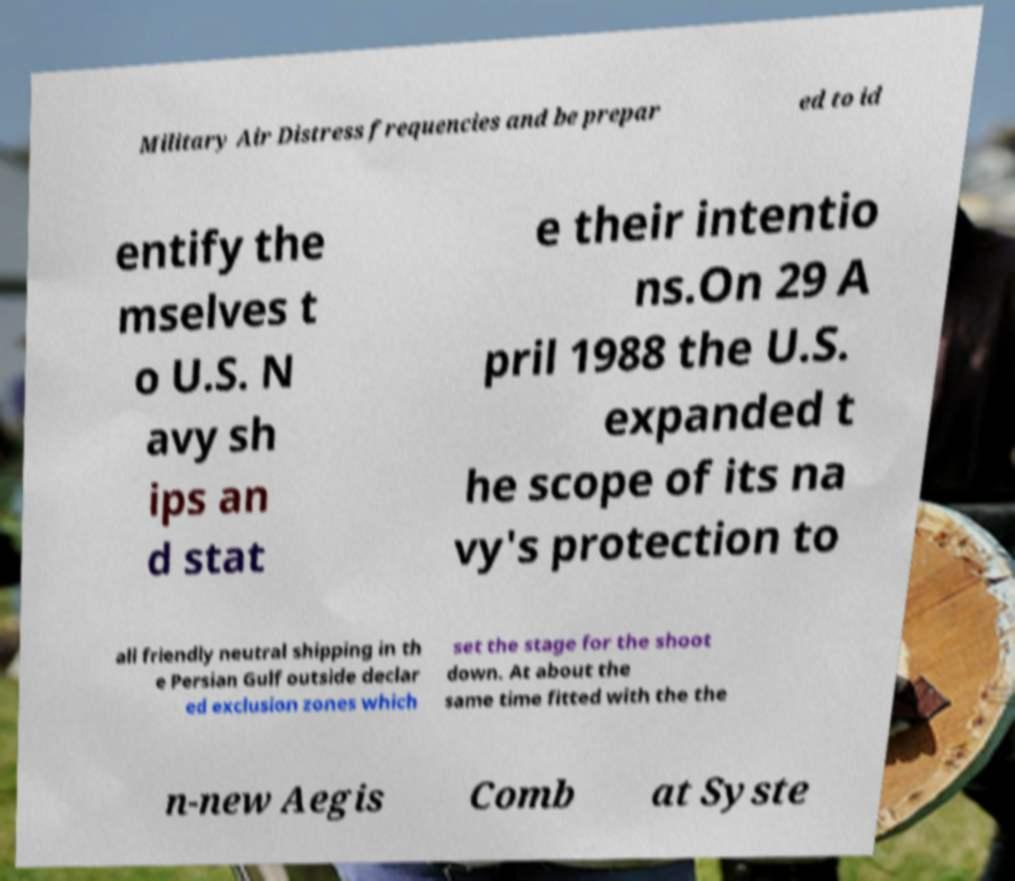Please identify and transcribe the text found in this image. Military Air Distress frequencies and be prepar ed to id entify the mselves t o U.S. N avy sh ips an d stat e their intentio ns.On 29 A pril 1988 the U.S. expanded t he scope of its na vy's protection to all friendly neutral shipping in th e Persian Gulf outside declar ed exclusion zones which set the stage for the shoot down. At about the same time fitted with the the n-new Aegis Comb at Syste 